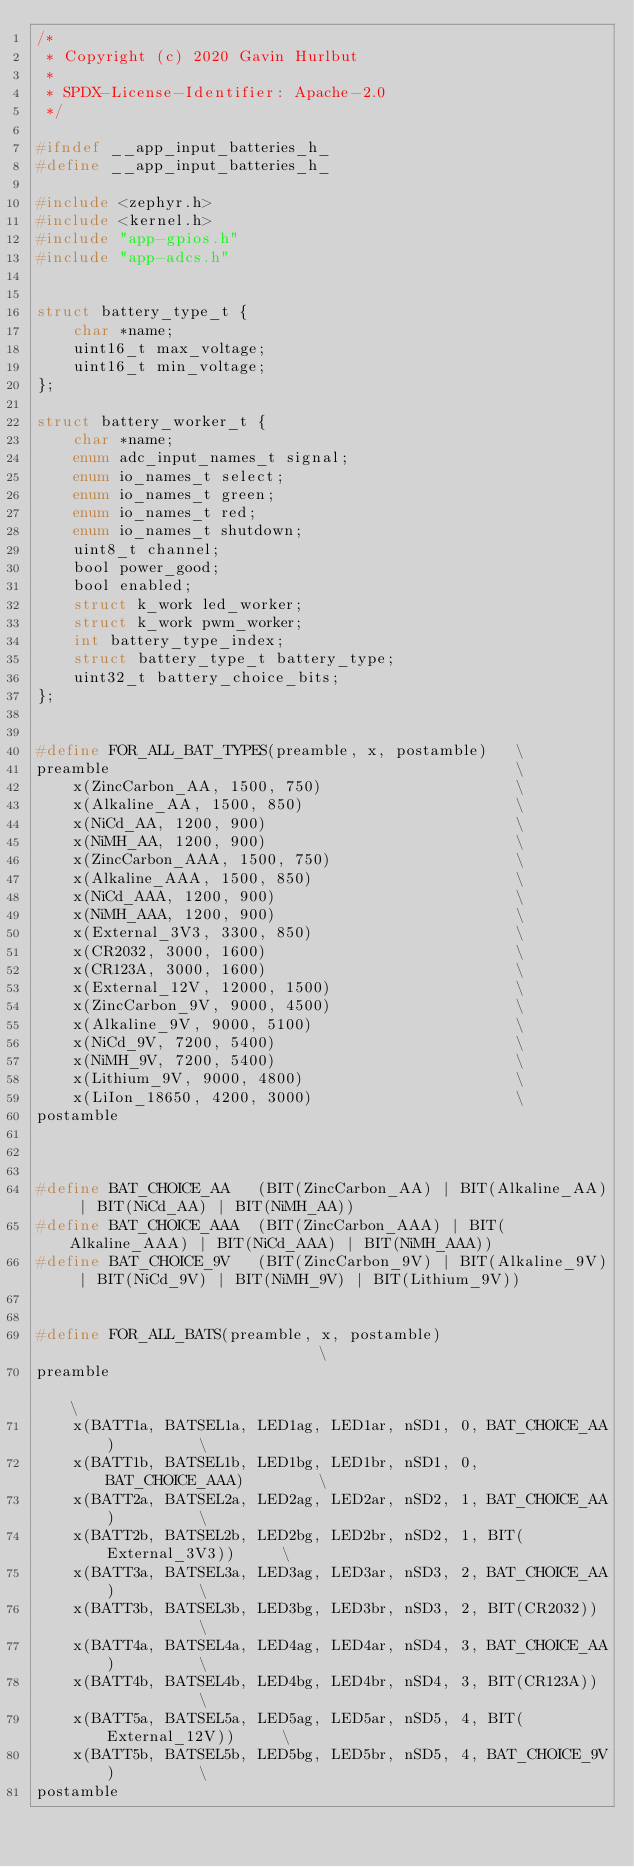Convert code to text. <code><loc_0><loc_0><loc_500><loc_500><_C_>/*
 * Copyright (c) 2020 Gavin Hurlbut
 *
 * SPDX-License-Identifier: Apache-2.0
 */

#ifndef __app_input_batteries_h_
#define __app_input_batteries_h_

#include <zephyr.h>
#include <kernel.h>
#include "app-gpios.h"
#include "app-adcs.h"


struct battery_type_t {
    char *name;
    uint16_t max_voltage;
    uint16_t min_voltage;
};

struct battery_worker_t {
    char *name;
    enum adc_input_names_t signal;
    enum io_names_t select;
    enum io_names_t green;
    enum io_names_t red;
    enum io_names_t shutdown;
    uint8_t channel;
    bool power_good;
    bool enabled;
    struct k_work led_worker;
    struct k_work pwm_worker;
    int battery_type_index;
    struct battery_type_t battery_type;
    uint32_t battery_choice_bits;
};


#define FOR_ALL_BAT_TYPES(preamble, x, postamble)   \
preamble                                            \
    x(ZincCarbon_AA, 1500, 750)                     \
    x(Alkaline_AA, 1500, 850)                       \
    x(NiCd_AA, 1200, 900)                           \
    x(NiMH_AA, 1200, 900)                           \
    x(ZincCarbon_AAA, 1500, 750)                    \
    x(Alkaline_AAA, 1500, 850)                      \
    x(NiCd_AAA, 1200, 900)                          \
    x(NiMH_AAA, 1200, 900)                          \
    x(External_3V3, 3300, 850)                      \
    x(CR2032, 3000, 1600)                           \
    x(CR123A, 3000, 1600)                           \
    x(External_12V, 12000, 1500)                    \
    x(ZincCarbon_9V, 9000, 4500)                    \
    x(Alkaline_9V, 9000, 5100)                      \
    x(NiCd_9V, 7200, 5400)                          \
    x(NiMH_9V, 7200, 5400)                          \
    x(Lithium_9V, 9000, 4800)                       \
    x(LiIon_18650, 4200, 3000)                      \
postamble



#define BAT_CHOICE_AA   (BIT(ZincCarbon_AA) | BIT(Alkaline_AA) | BIT(NiCd_AA) | BIT(NiMH_AA))
#define BAT_CHOICE_AAA  (BIT(ZincCarbon_AAA) | BIT(Alkaline_AAA) | BIT(NiCd_AAA) | BIT(NiMH_AAA))
#define BAT_CHOICE_9V   (BIT(ZincCarbon_9V) | BIT(Alkaline_9V) | BIT(NiCd_9V) | BIT(NiMH_9V) | BIT(Lithium_9V))


#define FOR_ALL_BATS(preamble, x, postamble)                            \
preamble                                                                \
    x(BATT1a, BATSEL1a, LED1ag, LED1ar, nSD1, 0, BAT_CHOICE_AA)         \
    x(BATT1b, BATSEL1b, LED1bg, LED1br, nSD1, 0, BAT_CHOICE_AAA)        \
    x(BATT2a, BATSEL2a, LED2ag, LED2ar, nSD2, 1, BAT_CHOICE_AA)         \
    x(BATT2b, BATSEL2b, LED2bg, LED2br, nSD2, 1, BIT(External_3V3))     \
    x(BATT3a, BATSEL3a, LED3ag, LED3ar, nSD3, 2, BAT_CHOICE_AA)         \
    x(BATT3b, BATSEL3b, LED3bg, LED3br, nSD3, 2, BIT(CR2032))           \
    x(BATT4a, BATSEL4a, LED4ag, LED4ar, nSD4, 3, BAT_CHOICE_AA)         \
    x(BATT4b, BATSEL4b, LED4bg, LED4br, nSD4, 3, BIT(CR123A))           \
    x(BATT5a, BATSEL5a, LED5ag, LED5ar, nSD5, 4, BIT(External_12V))     \
    x(BATT5b, BATSEL5b, LED5bg, LED5br, nSD5, 4, BAT_CHOICE_9V)         \
postamble
</code> 